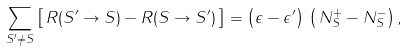Convert formula to latex. <formula><loc_0><loc_0><loc_500><loc_500>\sum _ { S ^ { \prime } \ne S } \left [ \, R ( S ^ { \prime } \to S ) - R ( S \to S ^ { \prime } ) \, \right ] = \left ( \epsilon - \epsilon ^ { \prime } \right ) \, \left ( \, N ^ { + } _ { S } - N ^ { - } _ { S } \right ) ,</formula> 